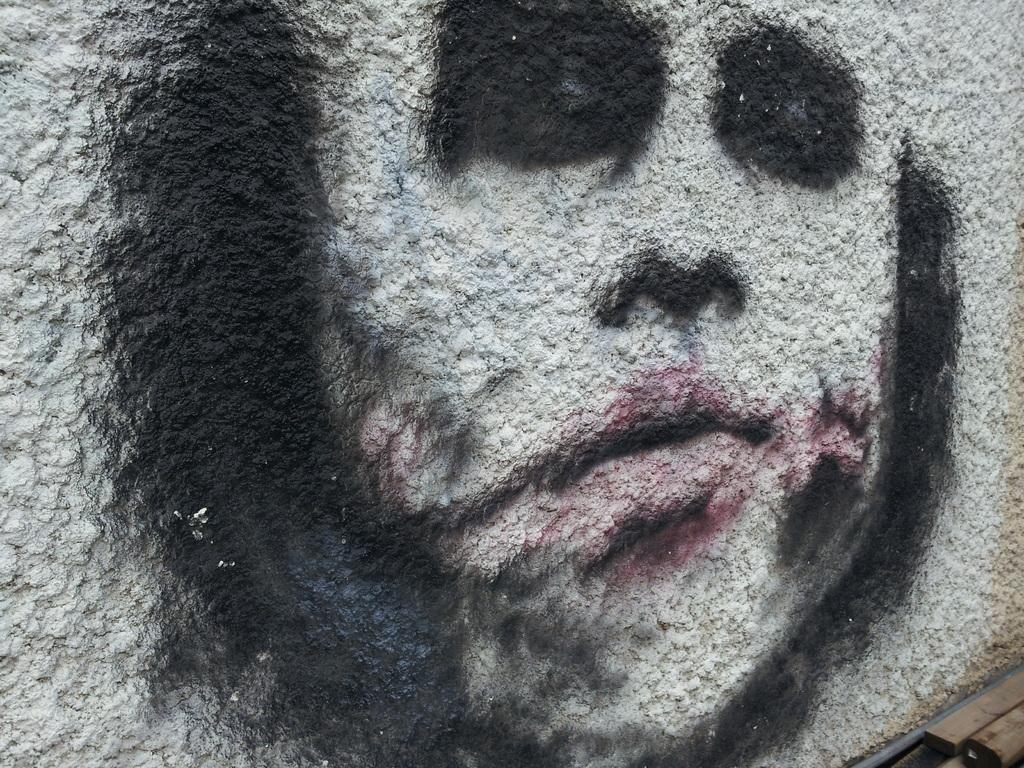What is depicted on the painting that is visible on the wall in the image? There is a painting of a joker on the wall in the image. What can be seen in the bottom right corner of the image? Pipes and wooden sticks are visible in the bottom right corner of the image. What advice does the mother give to the carpenter in the image? There is no mother or carpenter present in the image, so it is not possible to answer that question. Can you describe the joker's expression in the painting? The provided facts do not mention the joker's expression, so it cannot be described. 